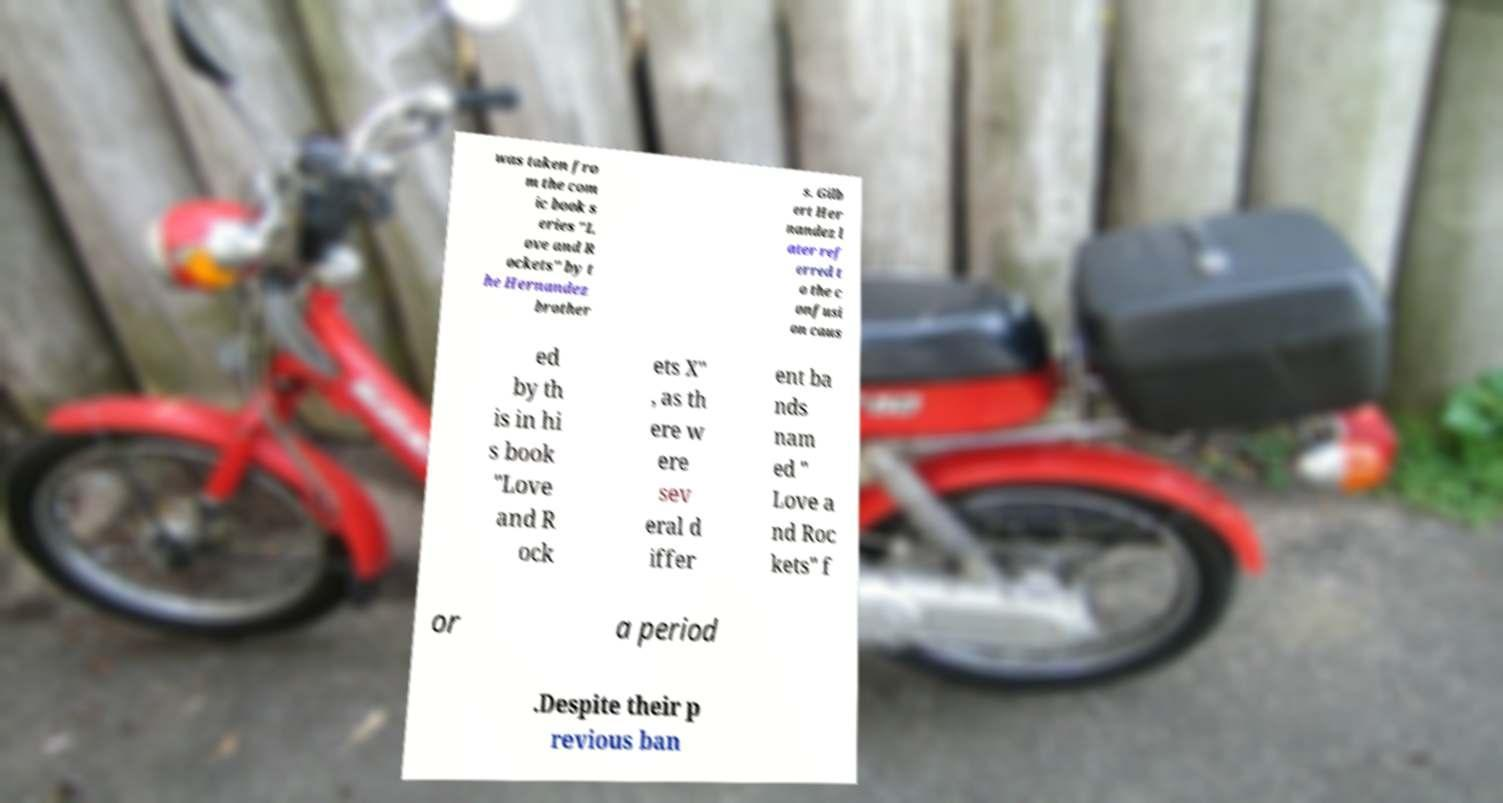Can you accurately transcribe the text from the provided image for me? was taken fro m the com ic book s eries "L ove and R ockets" by t he Hernandez brother s. Gilb ert Her nandez l ater ref erred t o the c onfusi on caus ed by th is in hi s book "Love and R ock ets X" , as th ere w ere sev eral d iffer ent ba nds nam ed " Love a nd Roc kets" f or a period .Despite their p revious ban 